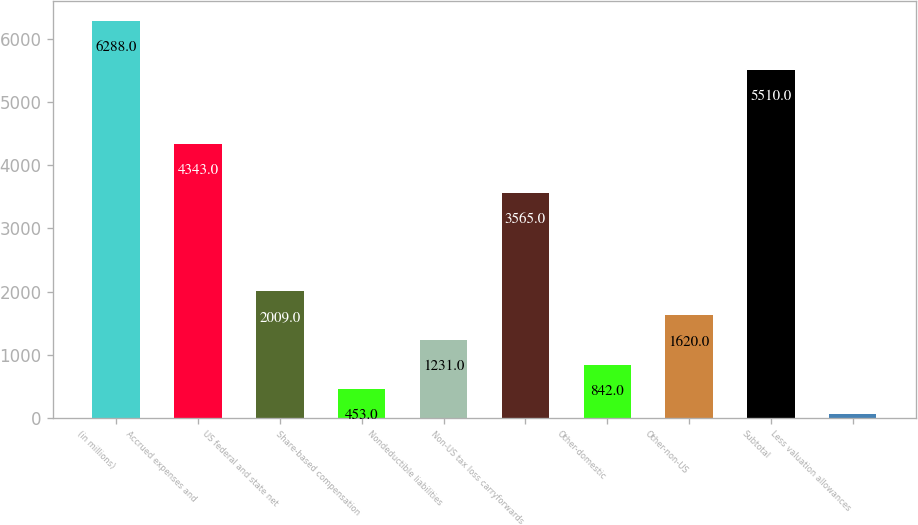Convert chart. <chart><loc_0><loc_0><loc_500><loc_500><bar_chart><fcel>(in millions)<fcel>Accrued expenses and<fcel>US federal and state net<fcel>Share-based compensation<fcel>Nondeductible liabilities<fcel>Non-US tax loss carryforwards<fcel>Other-domestic<fcel>Other-non-US<fcel>Subtotal<fcel>Less valuation allowances<nl><fcel>6288<fcel>4343<fcel>2009<fcel>453<fcel>1231<fcel>3565<fcel>842<fcel>1620<fcel>5510<fcel>64<nl></chart> 